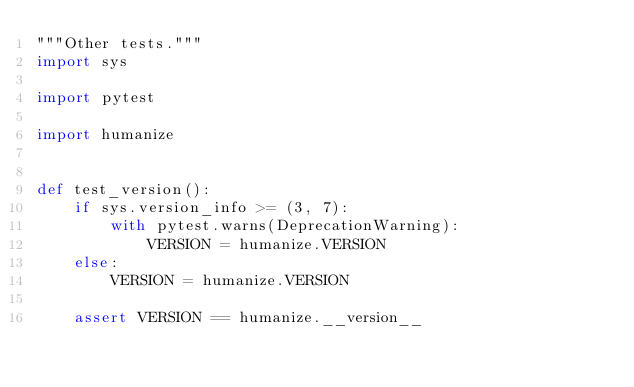<code> <loc_0><loc_0><loc_500><loc_500><_Python_>"""Other tests."""
import sys

import pytest

import humanize


def test_version():
    if sys.version_info >= (3, 7):
        with pytest.warns(DeprecationWarning):
            VERSION = humanize.VERSION
    else:
        VERSION = humanize.VERSION

    assert VERSION == humanize.__version__
</code> 